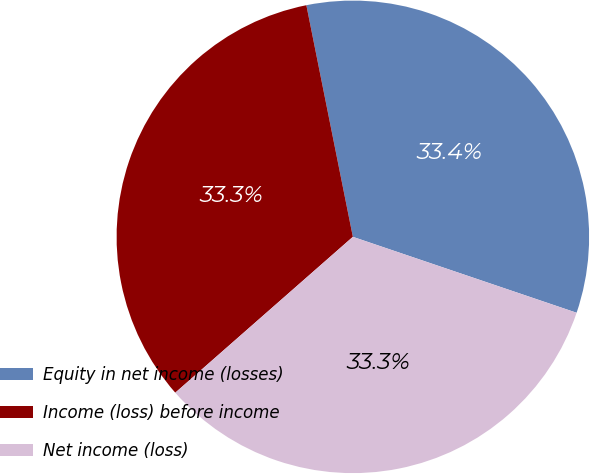<chart> <loc_0><loc_0><loc_500><loc_500><pie_chart><fcel>Equity in net income (losses)<fcel>Income (loss) before income<fcel>Net income (loss)<nl><fcel>33.36%<fcel>33.31%<fcel>33.33%<nl></chart> 